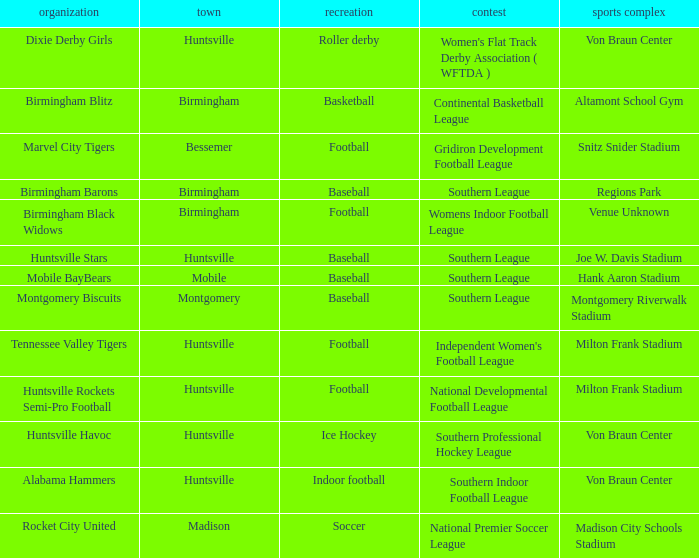Which city has a club called the Huntsville Stars? Huntsville. 